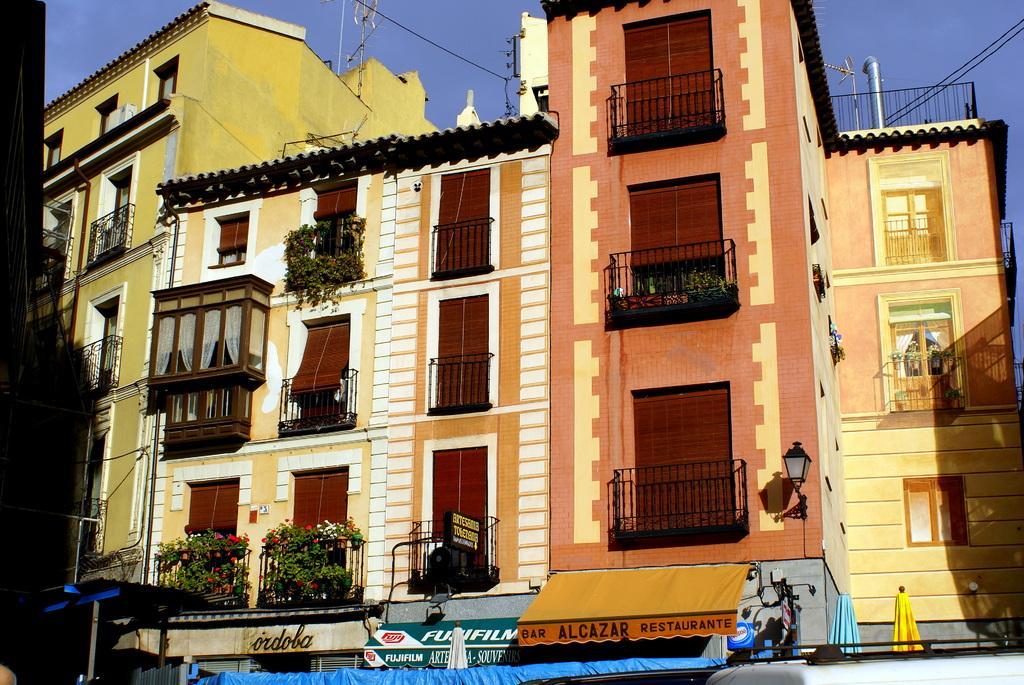Could you give a brief overview of what you see in this image? In the picture we can see the building with windows and under it we can see the shop boards and we can see the sky from the top of the building. 